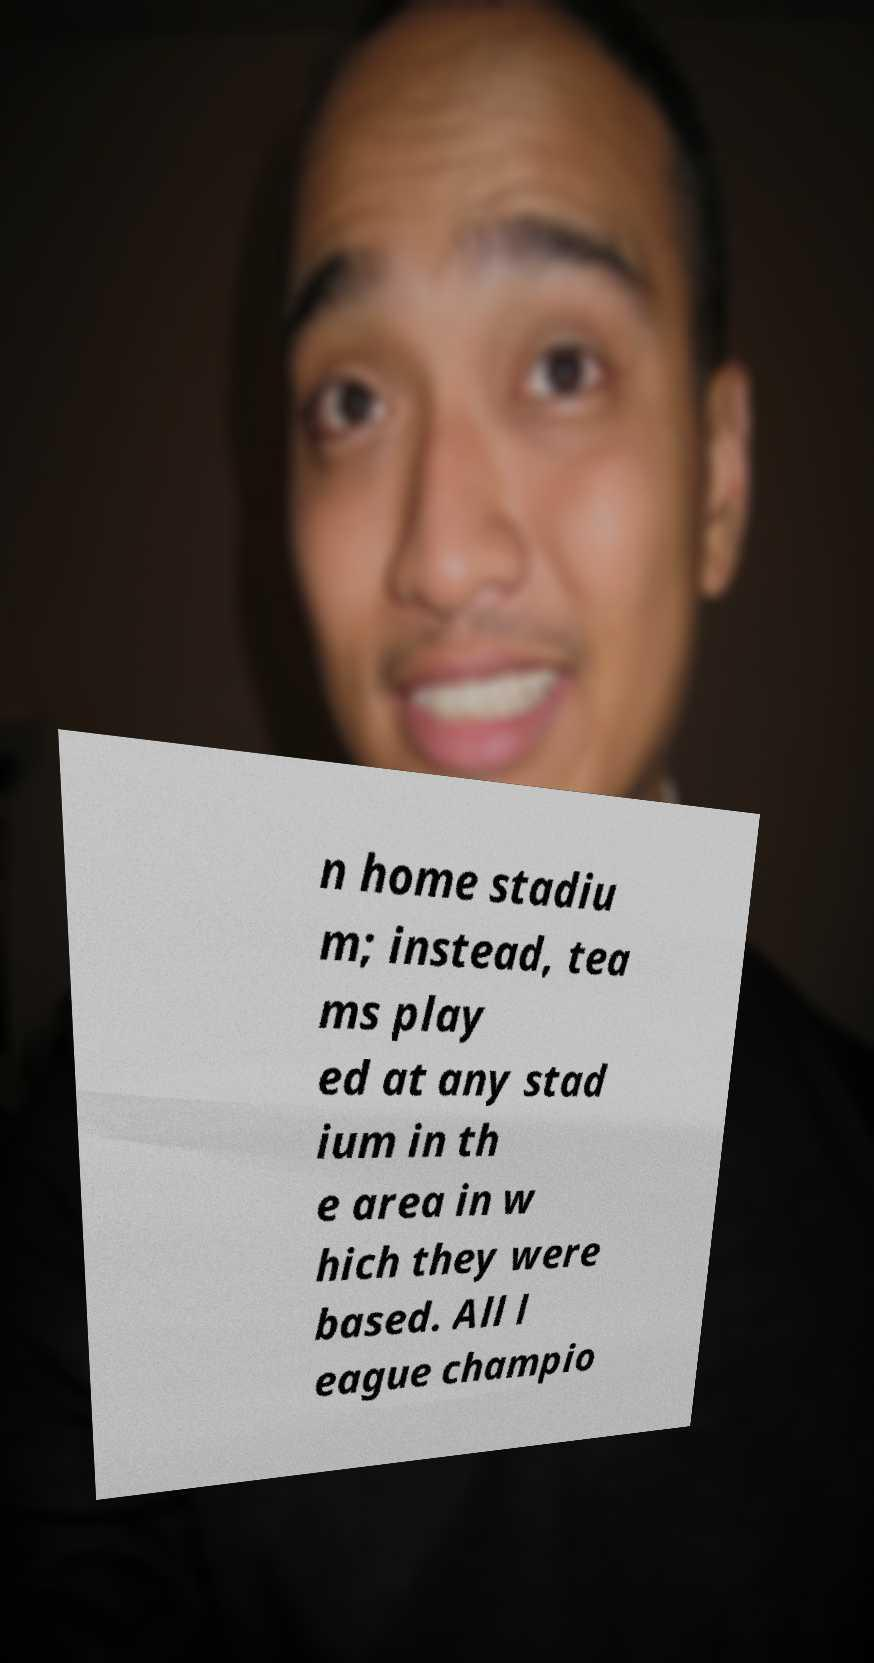Can you read and provide the text displayed in the image?This photo seems to have some interesting text. Can you extract and type it out for me? n home stadiu m; instead, tea ms play ed at any stad ium in th e area in w hich they were based. All l eague champio 